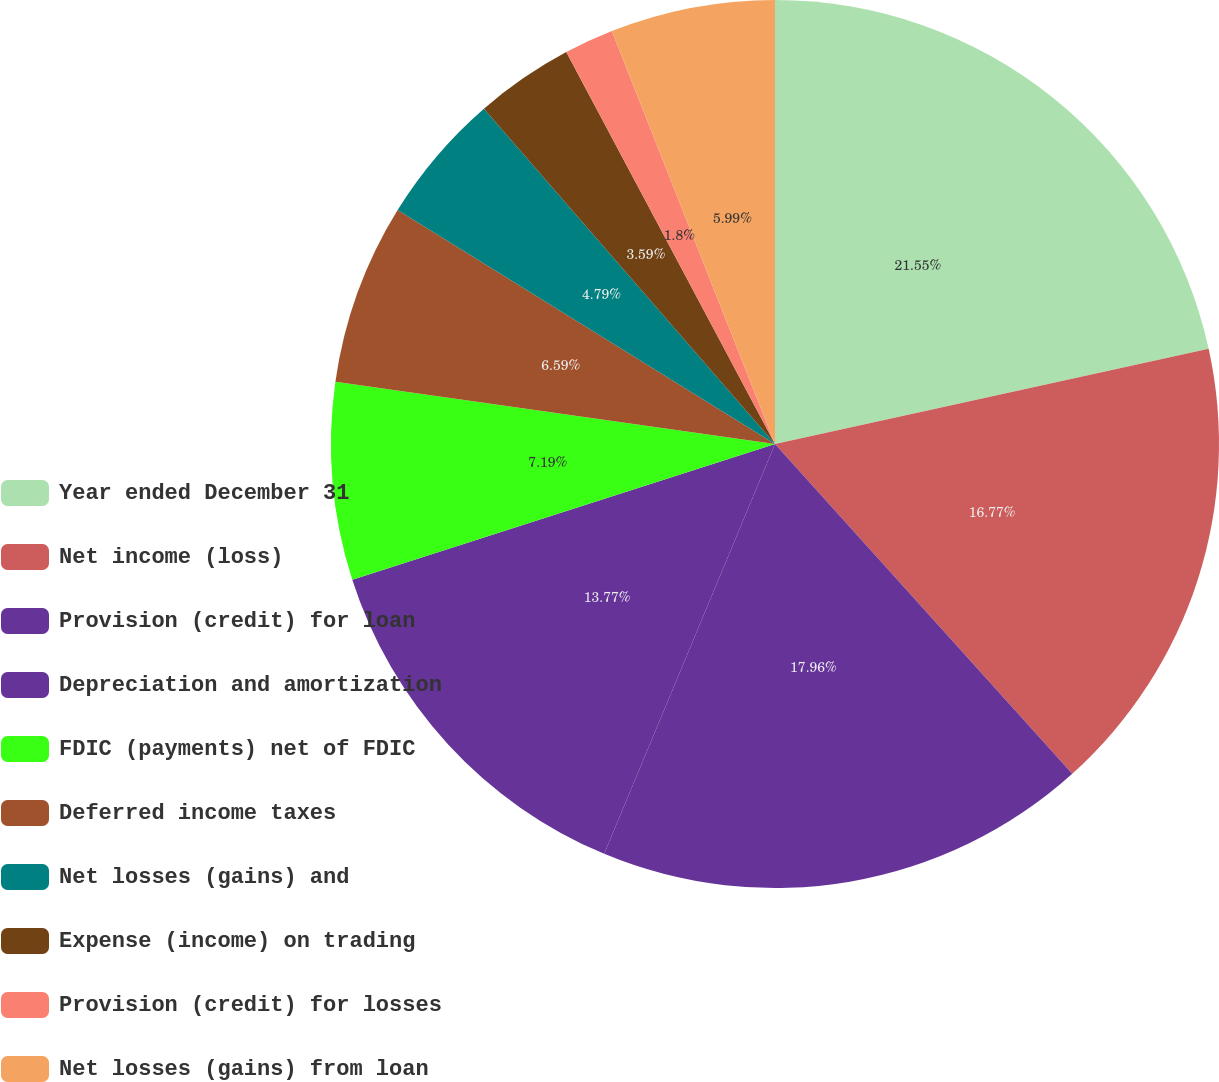Convert chart to OTSL. <chart><loc_0><loc_0><loc_500><loc_500><pie_chart><fcel>Year ended December 31<fcel>Net income (loss)<fcel>Provision (credit) for loan<fcel>Depreciation and amortization<fcel>FDIC (payments) net of FDIC<fcel>Deferred income taxes<fcel>Net losses (gains) and<fcel>Expense (income) on trading<fcel>Provision (credit) for losses<fcel>Net losses (gains) from loan<nl><fcel>21.56%<fcel>16.77%<fcel>17.96%<fcel>13.77%<fcel>7.19%<fcel>6.59%<fcel>4.79%<fcel>3.59%<fcel>1.8%<fcel>5.99%<nl></chart> 